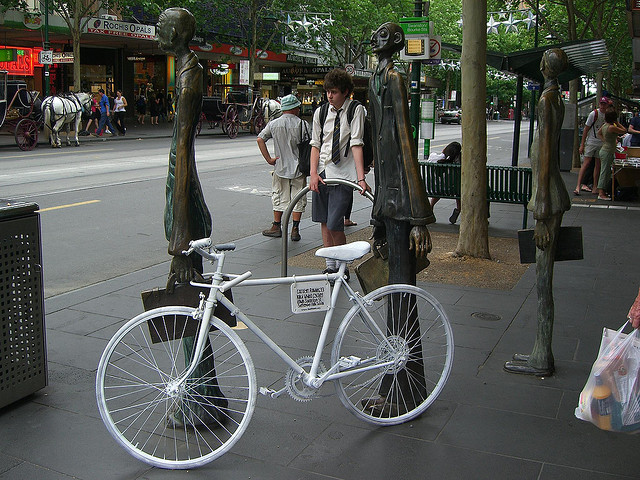Please extract the text content from this image. ROCHS OPALS 